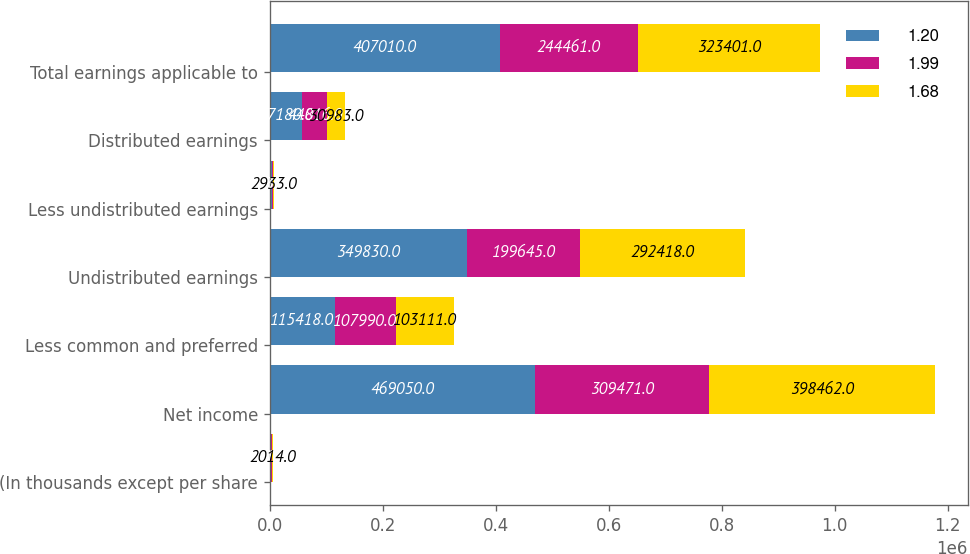<chart> <loc_0><loc_0><loc_500><loc_500><stacked_bar_chart><ecel><fcel>(In thousands except per share<fcel>Net income<fcel>Less common and preferred<fcel>Undistributed earnings<fcel>Less undistributed earnings<fcel>Distributed earnings<fcel>Total earnings applicable to<nl><fcel>1.2<fcel>2016<fcel>469050<fcel>115418<fcel>349830<fcel>3802<fcel>57180<fcel>407010<nl><fcel>1.99<fcel>2015<fcel>309471<fcel>107990<fcel>199645<fcel>1836<fcel>44816<fcel>244461<nl><fcel>1.68<fcel>2014<fcel>398462<fcel>103111<fcel>292418<fcel>2933<fcel>30983<fcel>323401<nl></chart> 